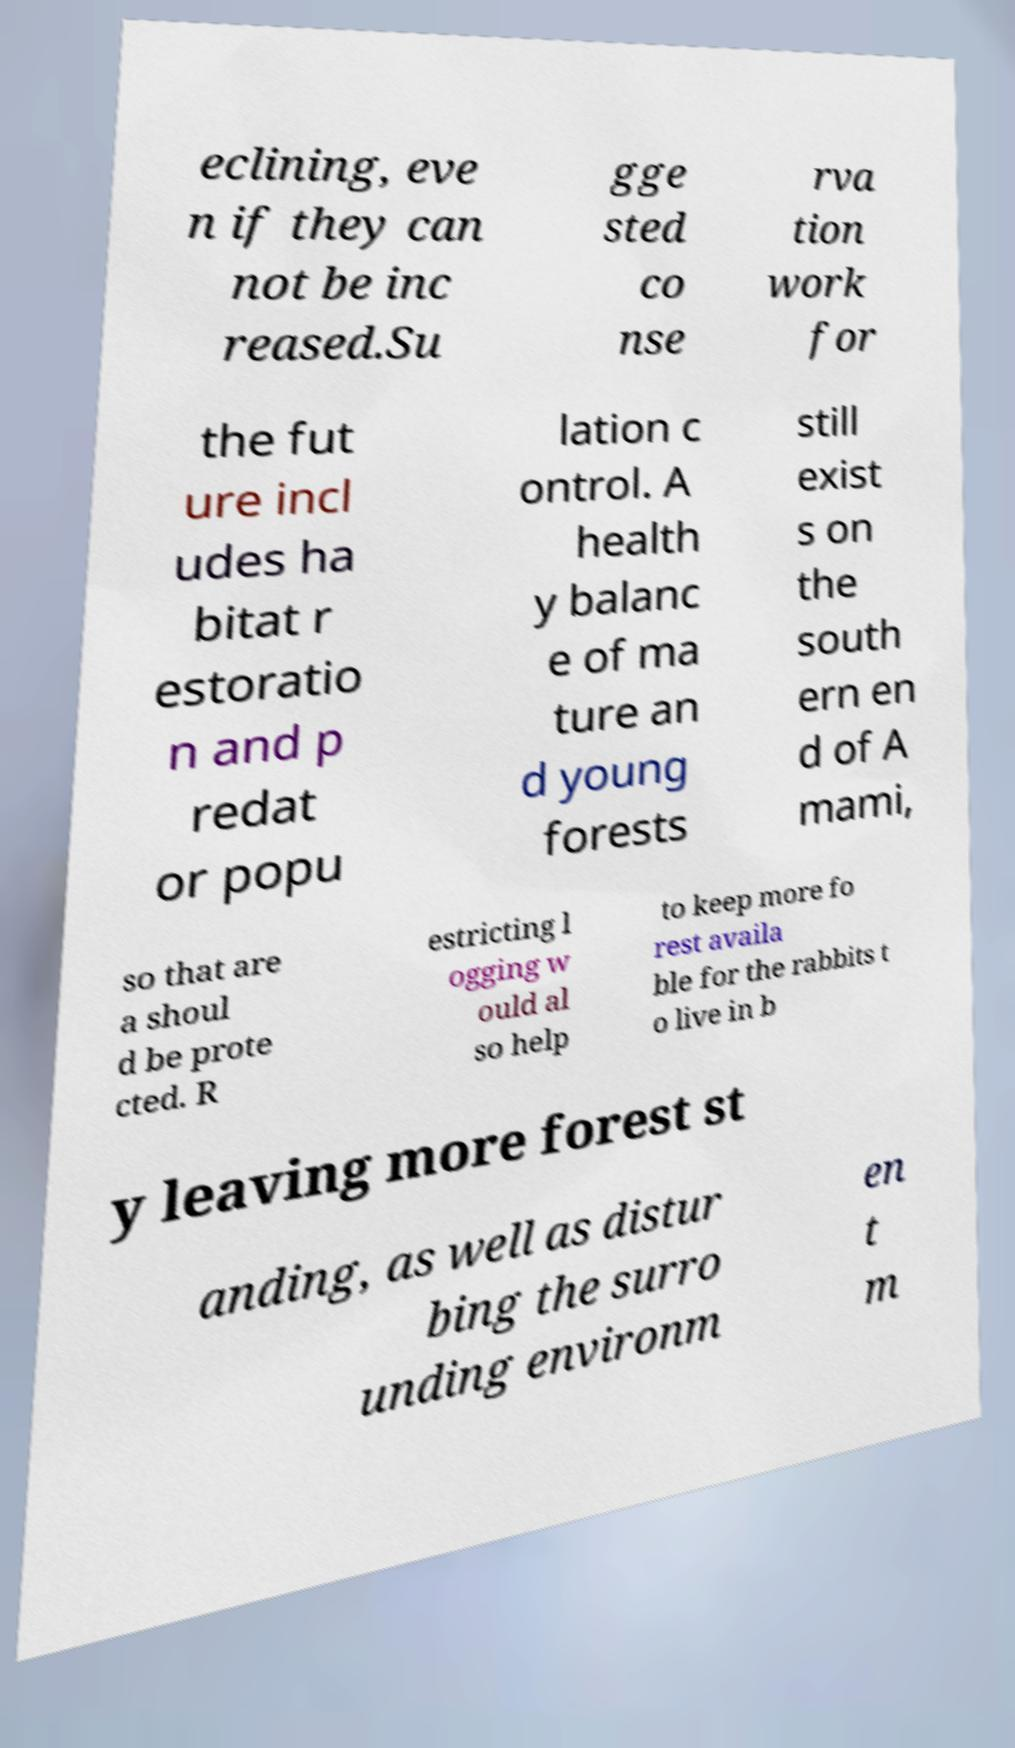For documentation purposes, I need the text within this image transcribed. Could you provide that? eclining, eve n if they can not be inc reased.Su gge sted co nse rva tion work for the fut ure incl udes ha bitat r estoratio n and p redat or popu lation c ontrol. A health y balanc e of ma ture an d young forests still exist s on the south ern en d of A mami, so that are a shoul d be prote cted. R estricting l ogging w ould al so help to keep more fo rest availa ble for the rabbits t o live in b y leaving more forest st anding, as well as distur bing the surro unding environm en t m 